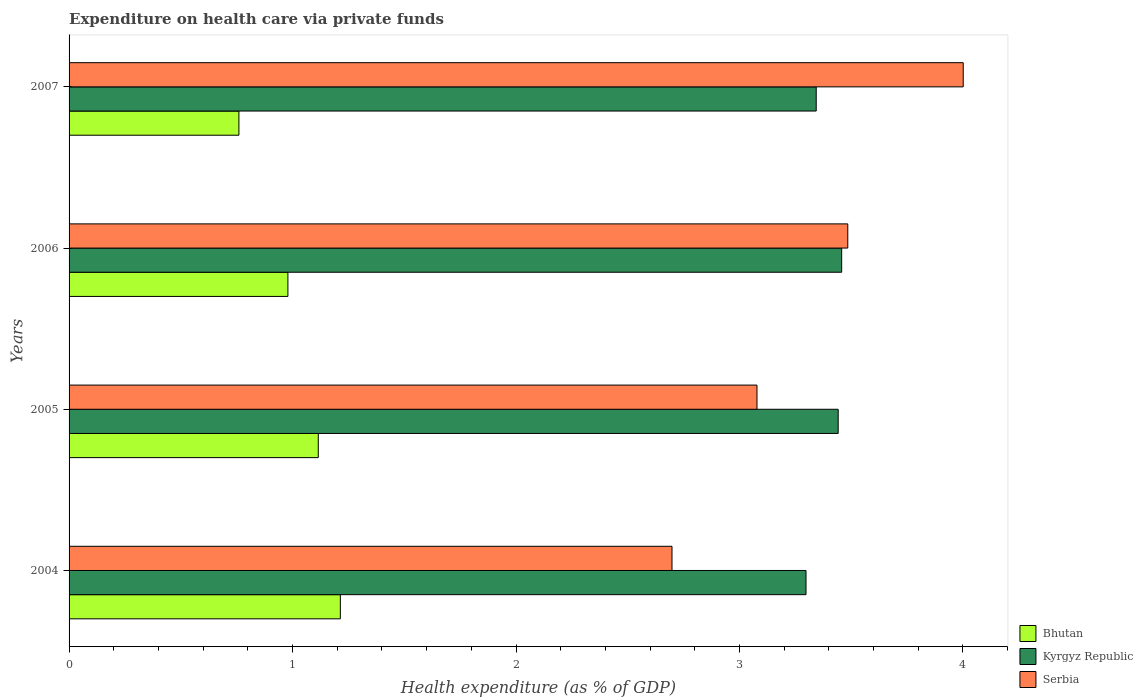How many different coloured bars are there?
Offer a terse response. 3. How many groups of bars are there?
Provide a succinct answer. 4. Are the number of bars on each tick of the Y-axis equal?
Offer a very short reply. Yes. What is the label of the 3rd group of bars from the top?
Provide a short and direct response. 2005. In how many cases, is the number of bars for a given year not equal to the number of legend labels?
Your answer should be compact. 0. What is the expenditure made on health care in Serbia in 2007?
Offer a terse response. 4. Across all years, what is the maximum expenditure made on health care in Kyrgyz Republic?
Make the answer very short. 3.46. Across all years, what is the minimum expenditure made on health care in Kyrgyz Republic?
Offer a terse response. 3.3. What is the total expenditure made on health care in Bhutan in the graph?
Ensure brevity in your answer.  4.07. What is the difference between the expenditure made on health care in Bhutan in 2004 and that in 2005?
Offer a terse response. 0.1. What is the difference between the expenditure made on health care in Kyrgyz Republic in 2004 and the expenditure made on health care in Serbia in 2007?
Your response must be concise. -0.7. What is the average expenditure made on health care in Serbia per year?
Give a very brief answer. 3.32. In the year 2006, what is the difference between the expenditure made on health care in Bhutan and expenditure made on health care in Serbia?
Ensure brevity in your answer.  -2.51. What is the ratio of the expenditure made on health care in Bhutan in 2004 to that in 2006?
Give a very brief answer. 1.24. Is the expenditure made on health care in Kyrgyz Republic in 2004 less than that in 2007?
Offer a terse response. Yes. Is the difference between the expenditure made on health care in Bhutan in 2004 and 2007 greater than the difference between the expenditure made on health care in Serbia in 2004 and 2007?
Provide a short and direct response. Yes. What is the difference between the highest and the second highest expenditure made on health care in Serbia?
Offer a very short reply. 0.52. What is the difference between the highest and the lowest expenditure made on health care in Kyrgyz Republic?
Provide a short and direct response. 0.16. Is the sum of the expenditure made on health care in Bhutan in 2005 and 2006 greater than the maximum expenditure made on health care in Serbia across all years?
Provide a short and direct response. No. What does the 2nd bar from the top in 2007 represents?
Offer a very short reply. Kyrgyz Republic. What does the 1st bar from the bottom in 2004 represents?
Provide a succinct answer. Bhutan. Are all the bars in the graph horizontal?
Make the answer very short. Yes. What is the difference between two consecutive major ticks on the X-axis?
Offer a terse response. 1. Are the values on the major ticks of X-axis written in scientific E-notation?
Offer a very short reply. No. Where does the legend appear in the graph?
Provide a succinct answer. Bottom right. What is the title of the graph?
Give a very brief answer. Expenditure on health care via private funds. Does "Kenya" appear as one of the legend labels in the graph?
Your answer should be compact. No. What is the label or title of the X-axis?
Offer a very short reply. Health expenditure (as % of GDP). What is the Health expenditure (as % of GDP) in Bhutan in 2004?
Provide a succinct answer. 1.21. What is the Health expenditure (as % of GDP) in Kyrgyz Republic in 2004?
Provide a short and direct response. 3.3. What is the Health expenditure (as % of GDP) of Serbia in 2004?
Ensure brevity in your answer.  2.7. What is the Health expenditure (as % of GDP) of Bhutan in 2005?
Give a very brief answer. 1.12. What is the Health expenditure (as % of GDP) in Kyrgyz Republic in 2005?
Your answer should be very brief. 3.44. What is the Health expenditure (as % of GDP) of Serbia in 2005?
Your response must be concise. 3.08. What is the Health expenditure (as % of GDP) of Bhutan in 2006?
Provide a succinct answer. 0.98. What is the Health expenditure (as % of GDP) of Kyrgyz Republic in 2006?
Ensure brevity in your answer.  3.46. What is the Health expenditure (as % of GDP) in Serbia in 2006?
Your answer should be compact. 3.48. What is the Health expenditure (as % of GDP) in Bhutan in 2007?
Keep it short and to the point. 0.76. What is the Health expenditure (as % of GDP) of Kyrgyz Republic in 2007?
Your answer should be very brief. 3.34. What is the Health expenditure (as % of GDP) of Serbia in 2007?
Make the answer very short. 4. Across all years, what is the maximum Health expenditure (as % of GDP) of Bhutan?
Offer a very short reply. 1.21. Across all years, what is the maximum Health expenditure (as % of GDP) in Kyrgyz Republic?
Provide a succinct answer. 3.46. Across all years, what is the maximum Health expenditure (as % of GDP) of Serbia?
Offer a terse response. 4. Across all years, what is the minimum Health expenditure (as % of GDP) in Bhutan?
Provide a short and direct response. 0.76. Across all years, what is the minimum Health expenditure (as % of GDP) in Kyrgyz Republic?
Offer a terse response. 3.3. Across all years, what is the minimum Health expenditure (as % of GDP) in Serbia?
Provide a short and direct response. 2.7. What is the total Health expenditure (as % of GDP) of Bhutan in the graph?
Your answer should be compact. 4.07. What is the total Health expenditure (as % of GDP) of Kyrgyz Republic in the graph?
Offer a terse response. 13.54. What is the total Health expenditure (as % of GDP) in Serbia in the graph?
Keep it short and to the point. 13.26. What is the difference between the Health expenditure (as % of GDP) of Bhutan in 2004 and that in 2005?
Keep it short and to the point. 0.1. What is the difference between the Health expenditure (as % of GDP) of Kyrgyz Republic in 2004 and that in 2005?
Your answer should be very brief. -0.14. What is the difference between the Health expenditure (as % of GDP) in Serbia in 2004 and that in 2005?
Ensure brevity in your answer.  -0.38. What is the difference between the Health expenditure (as % of GDP) in Bhutan in 2004 and that in 2006?
Provide a short and direct response. 0.23. What is the difference between the Health expenditure (as % of GDP) of Kyrgyz Republic in 2004 and that in 2006?
Keep it short and to the point. -0.16. What is the difference between the Health expenditure (as % of GDP) of Serbia in 2004 and that in 2006?
Offer a terse response. -0.79. What is the difference between the Health expenditure (as % of GDP) in Bhutan in 2004 and that in 2007?
Ensure brevity in your answer.  0.45. What is the difference between the Health expenditure (as % of GDP) in Kyrgyz Republic in 2004 and that in 2007?
Ensure brevity in your answer.  -0.05. What is the difference between the Health expenditure (as % of GDP) of Serbia in 2004 and that in 2007?
Keep it short and to the point. -1.3. What is the difference between the Health expenditure (as % of GDP) in Bhutan in 2005 and that in 2006?
Your answer should be very brief. 0.14. What is the difference between the Health expenditure (as % of GDP) in Kyrgyz Republic in 2005 and that in 2006?
Keep it short and to the point. -0.02. What is the difference between the Health expenditure (as % of GDP) in Serbia in 2005 and that in 2006?
Give a very brief answer. -0.41. What is the difference between the Health expenditure (as % of GDP) of Bhutan in 2005 and that in 2007?
Ensure brevity in your answer.  0.36. What is the difference between the Health expenditure (as % of GDP) of Kyrgyz Republic in 2005 and that in 2007?
Ensure brevity in your answer.  0.1. What is the difference between the Health expenditure (as % of GDP) in Serbia in 2005 and that in 2007?
Offer a very short reply. -0.92. What is the difference between the Health expenditure (as % of GDP) in Bhutan in 2006 and that in 2007?
Keep it short and to the point. 0.22. What is the difference between the Health expenditure (as % of GDP) of Kyrgyz Republic in 2006 and that in 2007?
Provide a succinct answer. 0.11. What is the difference between the Health expenditure (as % of GDP) of Serbia in 2006 and that in 2007?
Offer a terse response. -0.52. What is the difference between the Health expenditure (as % of GDP) of Bhutan in 2004 and the Health expenditure (as % of GDP) of Kyrgyz Republic in 2005?
Your answer should be very brief. -2.23. What is the difference between the Health expenditure (as % of GDP) of Bhutan in 2004 and the Health expenditure (as % of GDP) of Serbia in 2005?
Offer a very short reply. -1.86. What is the difference between the Health expenditure (as % of GDP) in Kyrgyz Republic in 2004 and the Health expenditure (as % of GDP) in Serbia in 2005?
Provide a succinct answer. 0.22. What is the difference between the Health expenditure (as % of GDP) of Bhutan in 2004 and the Health expenditure (as % of GDP) of Kyrgyz Republic in 2006?
Ensure brevity in your answer.  -2.24. What is the difference between the Health expenditure (as % of GDP) in Bhutan in 2004 and the Health expenditure (as % of GDP) in Serbia in 2006?
Your answer should be compact. -2.27. What is the difference between the Health expenditure (as % of GDP) in Kyrgyz Republic in 2004 and the Health expenditure (as % of GDP) in Serbia in 2006?
Offer a terse response. -0.19. What is the difference between the Health expenditure (as % of GDP) in Bhutan in 2004 and the Health expenditure (as % of GDP) in Kyrgyz Republic in 2007?
Give a very brief answer. -2.13. What is the difference between the Health expenditure (as % of GDP) of Bhutan in 2004 and the Health expenditure (as % of GDP) of Serbia in 2007?
Make the answer very short. -2.79. What is the difference between the Health expenditure (as % of GDP) of Kyrgyz Republic in 2004 and the Health expenditure (as % of GDP) of Serbia in 2007?
Provide a short and direct response. -0.7. What is the difference between the Health expenditure (as % of GDP) of Bhutan in 2005 and the Health expenditure (as % of GDP) of Kyrgyz Republic in 2006?
Provide a short and direct response. -2.34. What is the difference between the Health expenditure (as % of GDP) in Bhutan in 2005 and the Health expenditure (as % of GDP) in Serbia in 2006?
Ensure brevity in your answer.  -2.37. What is the difference between the Health expenditure (as % of GDP) in Kyrgyz Republic in 2005 and the Health expenditure (as % of GDP) in Serbia in 2006?
Your answer should be compact. -0.04. What is the difference between the Health expenditure (as % of GDP) of Bhutan in 2005 and the Health expenditure (as % of GDP) of Kyrgyz Republic in 2007?
Your response must be concise. -2.23. What is the difference between the Health expenditure (as % of GDP) in Bhutan in 2005 and the Health expenditure (as % of GDP) in Serbia in 2007?
Keep it short and to the point. -2.89. What is the difference between the Health expenditure (as % of GDP) in Kyrgyz Republic in 2005 and the Health expenditure (as % of GDP) in Serbia in 2007?
Provide a succinct answer. -0.56. What is the difference between the Health expenditure (as % of GDP) in Bhutan in 2006 and the Health expenditure (as % of GDP) in Kyrgyz Republic in 2007?
Offer a very short reply. -2.36. What is the difference between the Health expenditure (as % of GDP) of Bhutan in 2006 and the Health expenditure (as % of GDP) of Serbia in 2007?
Offer a terse response. -3.02. What is the difference between the Health expenditure (as % of GDP) in Kyrgyz Republic in 2006 and the Health expenditure (as % of GDP) in Serbia in 2007?
Offer a terse response. -0.54. What is the average Health expenditure (as % of GDP) of Bhutan per year?
Offer a terse response. 1.02. What is the average Health expenditure (as % of GDP) in Kyrgyz Republic per year?
Make the answer very short. 3.38. What is the average Health expenditure (as % of GDP) of Serbia per year?
Make the answer very short. 3.32. In the year 2004, what is the difference between the Health expenditure (as % of GDP) in Bhutan and Health expenditure (as % of GDP) in Kyrgyz Republic?
Keep it short and to the point. -2.08. In the year 2004, what is the difference between the Health expenditure (as % of GDP) of Bhutan and Health expenditure (as % of GDP) of Serbia?
Offer a terse response. -1.48. In the year 2004, what is the difference between the Health expenditure (as % of GDP) of Kyrgyz Republic and Health expenditure (as % of GDP) of Serbia?
Give a very brief answer. 0.6. In the year 2005, what is the difference between the Health expenditure (as % of GDP) of Bhutan and Health expenditure (as % of GDP) of Kyrgyz Republic?
Your response must be concise. -2.33. In the year 2005, what is the difference between the Health expenditure (as % of GDP) of Bhutan and Health expenditure (as % of GDP) of Serbia?
Ensure brevity in your answer.  -1.96. In the year 2005, what is the difference between the Health expenditure (as % of GDP) of Kyrgyz Republic and Health expenditure (as % of GDP) of Serbia?
Provide a short and direct response. 0.36. In the year 2006, what is the difference between the Health expenditure (as % of GDP) in Bhutan and Health expenditure (as % of GDP) in Kyrgyz Republic?
Your answer should be very brief. -2.48. In the year 2006, what is the difference between the Health expenditure (as % of GDP) of Bhutan and Health expenditure (as % of GDP) of Serbia?
Give a very brief answer. -2.51. In the year 2006, what is the difference between the Health expenditure (as % of GDP) of Kyrgyz Republic and Health expenditure (as % of GDP) of Serbia?
Offer a terse response. -0.03. In the year 2007, what is the difference between the Health expenditure (as % of GDP) of Bhutan and Health expenditure (as % of GDP) of Kyrgyz Republic?
Provide a short and direct response. -2.58. In the year 2007, what is the difference between the Health expenditure (as % of GDP) in Bhutan and Health expenditure (as % of GDP) in Serbia?
Ensure brevity in your answer.  -3.24. In the year 2007, what is the difference between the Health expenditure (as % of GDP) of Kyrgyz Republic and Health expenditure (as % of GDP) of Serbia?
Provide a short and direct response. -0.66. What is the ratio of the Health expenditure (as % of GDP) of Bhutan in 2004 to that in 2005?
Make the answer very short. 1.09. What is the ratio of the Health expenditure (as % of GDP) of Kyrgyz Republic in 2004 to that in 2005?
Keep it short and to the point. 0.96. What is the ratio of the Health expenditure (as % of GDP) in Serbia in 2004 to that in 2005?
Offer a very short reply. 0.88. What is the ratio of the Health expenditure (as % of GDP) of Bhutan in 2004 to that in 2006?
Provide a succinct answer. 1.24. What is the ratio of the Health expenditure (as % of GDP) in Kyrgyz Republic in 2004 to that in 2006?
Offer a very short reply. 0.95. What is the ratio of the Health expenditure (as % of GDP) in Serbia in 2004 to that in 2006?
Your response must be concise. 0.77. What is the ratio of the Health expenditure (as % of GDP) in Bhutan in 2004 to that in 2007?
Offer a terse response. 1.6. What is the ratio of the Health expenditure (as % of GDP) of Kyrgyz Republic in 2004 to that in 2007?
Make the answer very short. 0.99. What is the ratio of the Health expenditure (as % of GDP) in Serbia in 2004 to that in 2007?
Offer a terse response. 0.67. What is the ratio of the Health expenditure (as % of GDP) in Bhutan in 2005 to that in 2006?
Your answer should be compact. 1.14. What is the ratio of the Health expenditure (as % of GDP) in Kyrgyz Republic in 2005 to that in 2006?
Provide a short and direct response. 1. What is the ratio of the Health expenditure (as % of GDP) in Serbia in 2005 to that in 2006?
Your answer should be very brief. 0.88. What is the ratio of the Health expenditure (as % of GDP) in Bhutan in 2005 to that in 2007?
Offer a terse response. 1.47. What is the ratio of the Health expenditure (as % of GDP) in Kyrgyz Republic in 2005 to that in 2007?
Offer a very short reply. 1.03. What is the ratio of the Health expenditure (as % of GDP) of Serbia in 2005 to that in 2007?
Provide a succinct answer. 0.77. What is the ratio of the Health expenditure (as % of GDP) of Bhutan in 2006 to that in 2007?
Make the answer very short. 1.29. What is the ratio of the Health expenditure (as % of GDP) in Kyrgyz Republic in 2006 to that in 2007?
Offer a very short reply. 1.03. What is the ratio of the Health expenditure (as % of GDP) in Serbia in 2006 to that in 2007?
Your response must be concise. 0.87. What is the difference between the highest and the second highest Health expenditure (as % of GDP) of Bhutan?
Your answer should be very brief. 0.1. What is the difference between the highest and the second highest Health expenditure (as % of GDP) in Kyrgyz Republic?
Provide a succinct answer. 0.02. What is the difference between the highest and the second highest Health expenditure (as % of GDP) in Serbia?
Give a very brief answer. 0.52. What is the difference between the highest and the lowest Health expenditure (as % of GDP) of Bhutan?
Your response must be concise. 0.45. What is the difference between the highest and the lowest Health expenditure (as % of GDP) in Kyrgyz Republic?
Give a very brief answer. 0.16. What is the difference between the highest and the lowest Health expenditure (as % of GDP) in Serbia?
Your response must be concise. 1.3. 